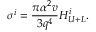Convert formula to latex. <formula><loc_0><loc_0><loc_500><loc_500>\sigma ^ { i } = \frac { \pi \alpha ^ { 2 } v } { 3 q ^ { 4 } } H _ { U + L } ^ { i } .</formula> 